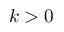<formula> <loc_0><loc_0><loc_500><loc_500>k > 0</formula> 